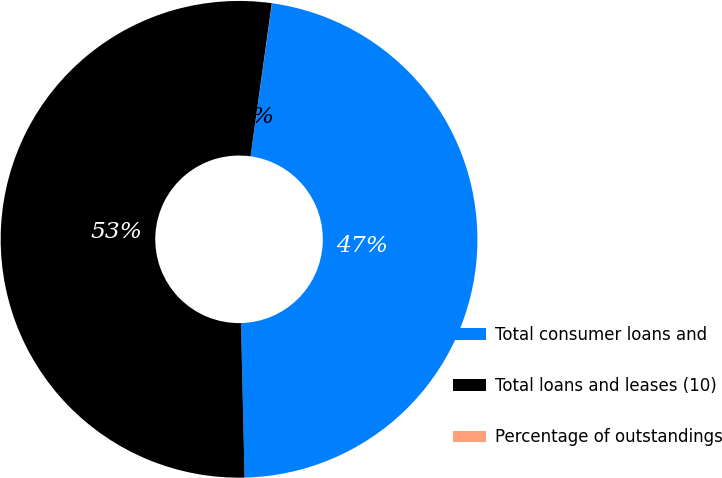Convert chart to OTSL. <chart><loc_0><loc_0><loc_500><loc_500><pie_chart><fcel>Total consumer loans and<fcel>Total loans and leases (10)<fcel>Percentage of outstandings<nl><fcel>47.42%<fcel>52.57%<fcel>0.01%<nl></chart> 